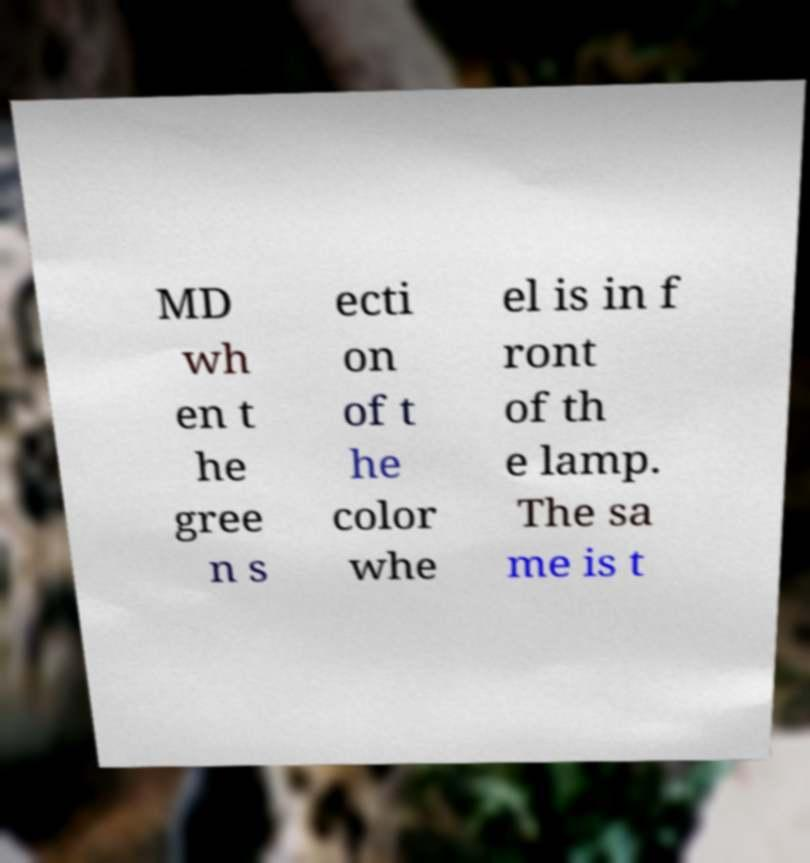What messages or text are displayed in this image? I need them in a readable, typed format. MD wh en t he gree n s ecti on of t he color whe el is in f ront of th e lamp. The sa me is t 